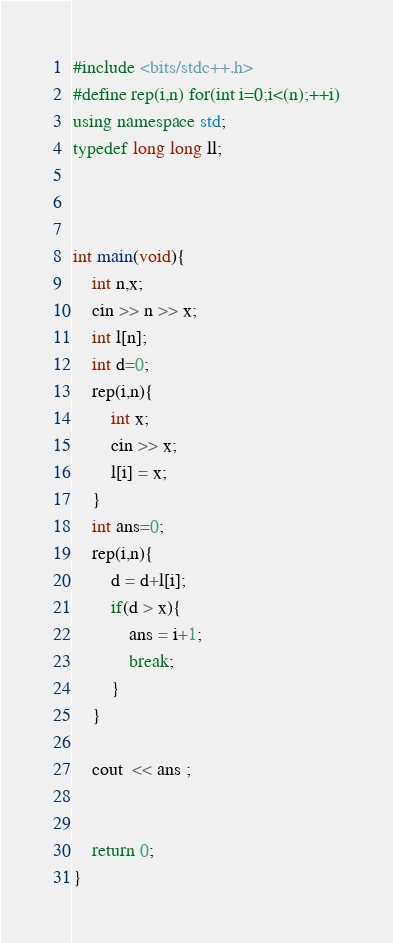Convert code to text. <code><loc_0><loc_0><loc_500><loc_500><_C++_>#include <bits/stdc++.h>
#define rep(i,n) for(int i=0;i<(n);++i)
using namespace std;
typedef long long ll;



int main(void){
    int n,x;
    cin >> n >> x;
    int l[n];
    int d=0;
    rep(i,n){
        int x;
        cin >> x;
        l[i] = x;
    }
    int ans=0;
    rep(i,n){
        d = d+l[i];
        if(d > x){
            ans = i+1;
            break;
        }
    }
    
    cout  << ans ;
    
    
    return 0;
}





















</code> 